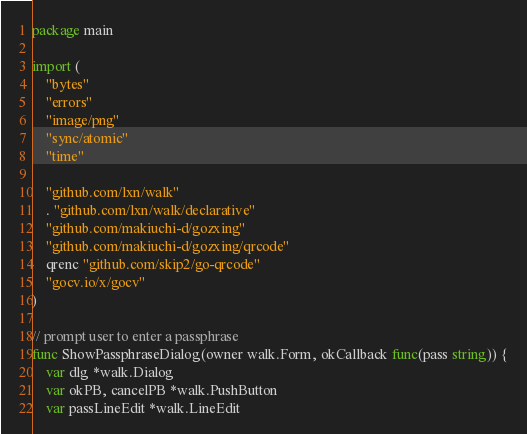Convert code to text. <code><loc_0><loc_0><loc_500><loc_500><_Go_>package main

import (
	"bytes"
	"errors"
	"image/png"
	"sync/atomic"
	"time"

	"github.com/lxn/walk"
	. "github.com/lxn/walk/declarative"
	"github.com/makiuchi-d/gozxing"
	"github.com/makiuchi-d/gozxing/qrcode"
	qrenc "github.com/skip2/go-qrcode"
	"gocv.io/x/gocv"
)

// prompt user to enter a passphrase
func ShowPassphraseDialog(owner walk.Form, okCallback func(pass string)) {
	var dlg *walk.Dialog
	var okPB, cancelPB *walk.PushButton
	var passLineEdit *walk.LineEdit
</code> 